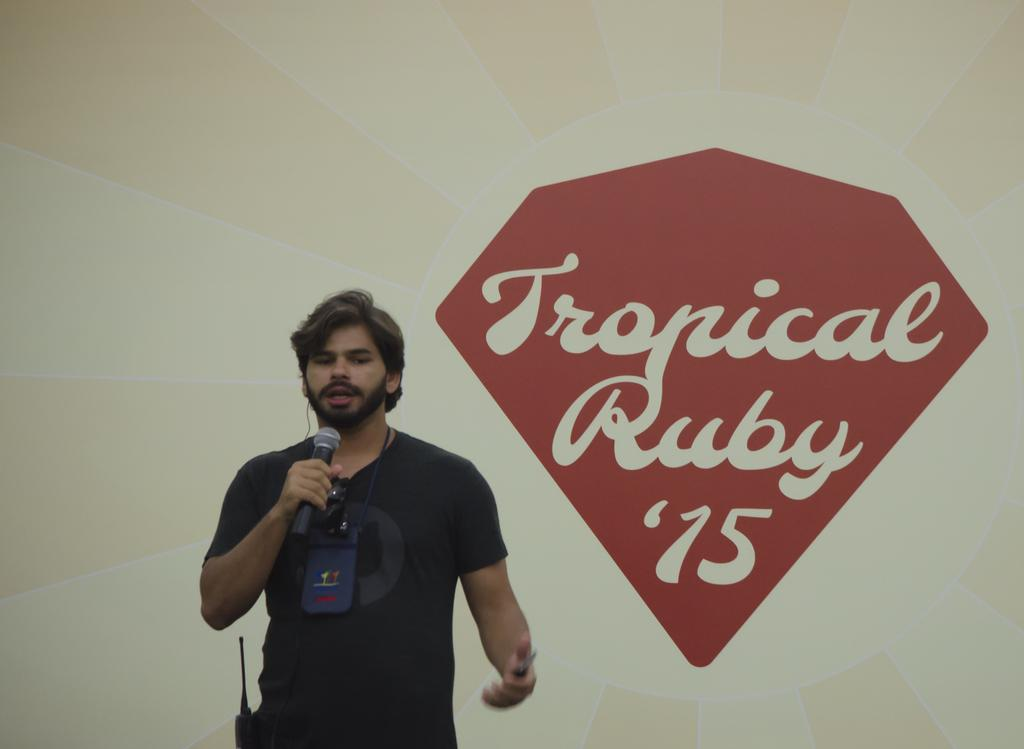What is the man in the image holding? The man is holding a mic in the image. What might the man be doing with the mic? The man might be using the mic for speaking or singing. Can you describe the background of the image? There is a wall with text on it in the background of the image. What type of produce is visible on the man's head in the image? There is no produce visible on the man's head in the image. 